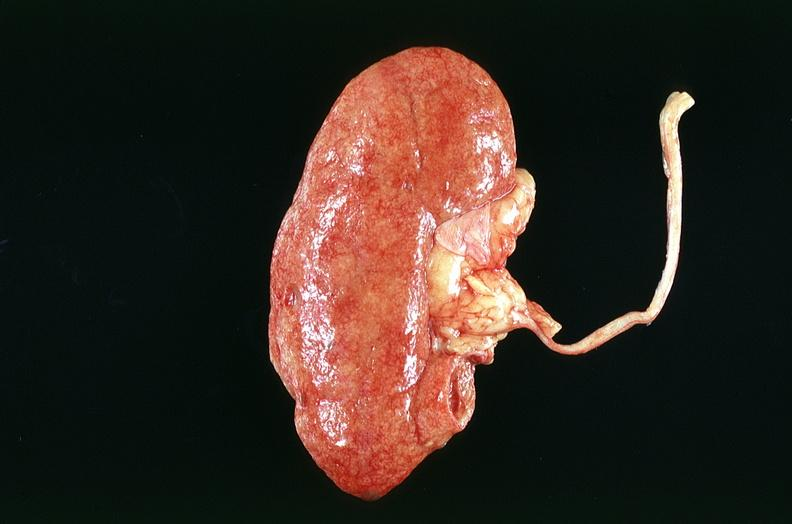what does this image show?
Answer the question using a single word or phrase. Kidney 